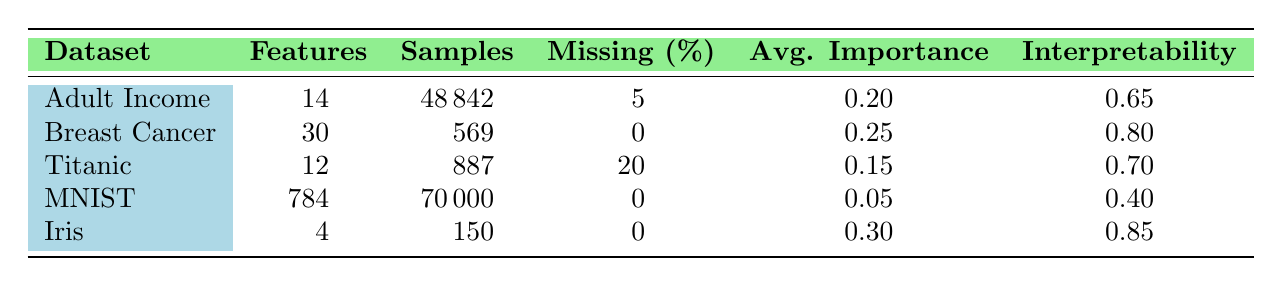What is the average interpretability score of all datasets? To find the average interpretability score, we sum the interpretability scores of all datasets: 0.65 (Adult Income) + 0.80 (Breast Cancer) + 0.70 (Titanic) + 0.40 (MNIST) + 0.85 (Iris) = 3.40. Then, we divide by the number of datasets, which is 5: 3.40 / 5 = 0.68.
Answer: 0.68 Which dataset has the highest average feature importance? By comparing the average feature importance values from the table, we see that the Iris dataset has the highest value of 0.30, while the others have lower values.
Answer: Iris Is the class label distribution of the Adult Income dataset imbalanced? According to the table, the class label distribution of the Adult Income dataset is explicitly stated as "Imbalanced." This verifies that the statement is true.
Answer: Yes How many features does the Titanic dataset have compared to the MNIST dataset? The Titanic dataset has 12 features, while the MNIST dataset has 784 features. To find the difference, we subtract: 784 - 12 = 772.
Answer: 772 Is there a dataset with missing values, and if so, which one has the highest percentage of missing values? Looking at the "Missing (%)" column, the Titanic dataset has 20% missing values which is the highest among all datasets. The other datasets either have 0% or a lower percentage.
Answer: Titanic 